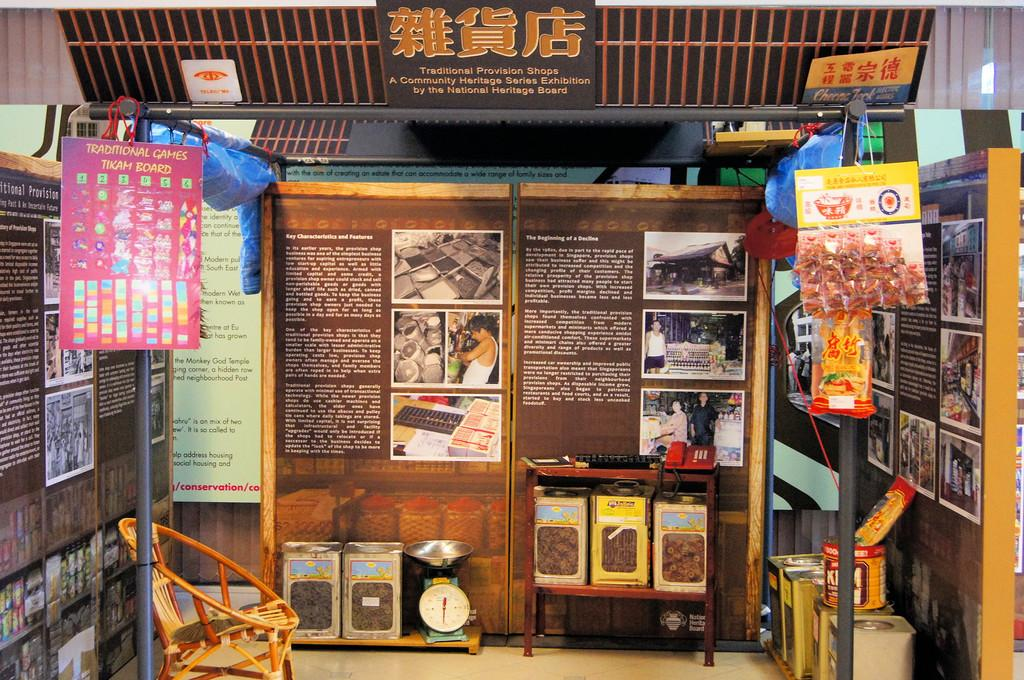Provide a one-sentence caption for the provided image. A traditional games tikam board is shown in a space filled with cultural posters and pictures. 